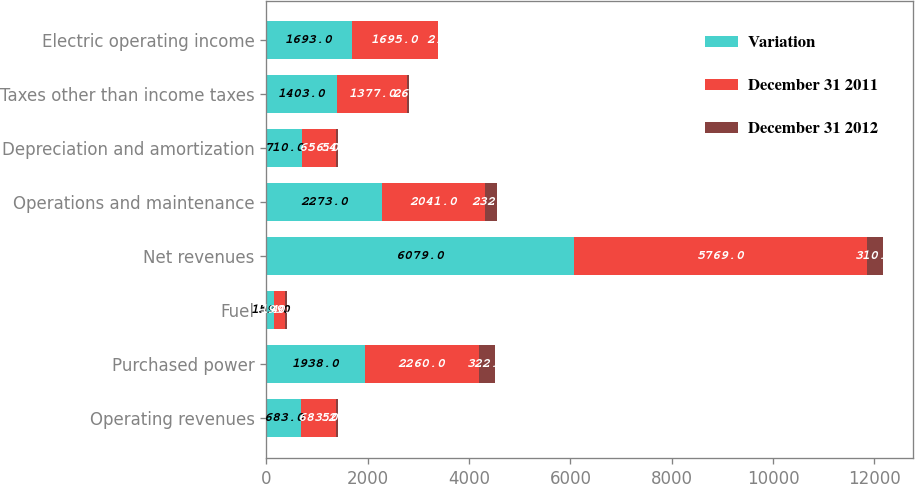Convert chart to OTSL. <chart><loc_0><loc_0><loc_500><loc_500><stacked_bar_chart><ecel><fcel>Operating revenues<fcel>Purchased power<fcel>Fuel<fcel>Net revenues<fcel>Operations and maintenance<fcel>Depreciation and amortization<fcel>Taxes other than income taxes<fcel>Electric operating income<nl><fcel>Variation<fcel>683<fcel>1938<fcel>159<fcel>6079<fcel>2273<fcel>710<fcel>1403<fcel>1693<nl><fcel>December 31 2011<fcel>683<fcel>2260<fcel>199<fcel>5769<fcel>2041<fcel>656<fcel>1377<fcel>1695<nl><fcel>December 31 2012<fcel>52<fcel>322<fcel>40<fcel>310<fcel>232<fcel>54<fcel>26<fcel>2<nl></chart> 